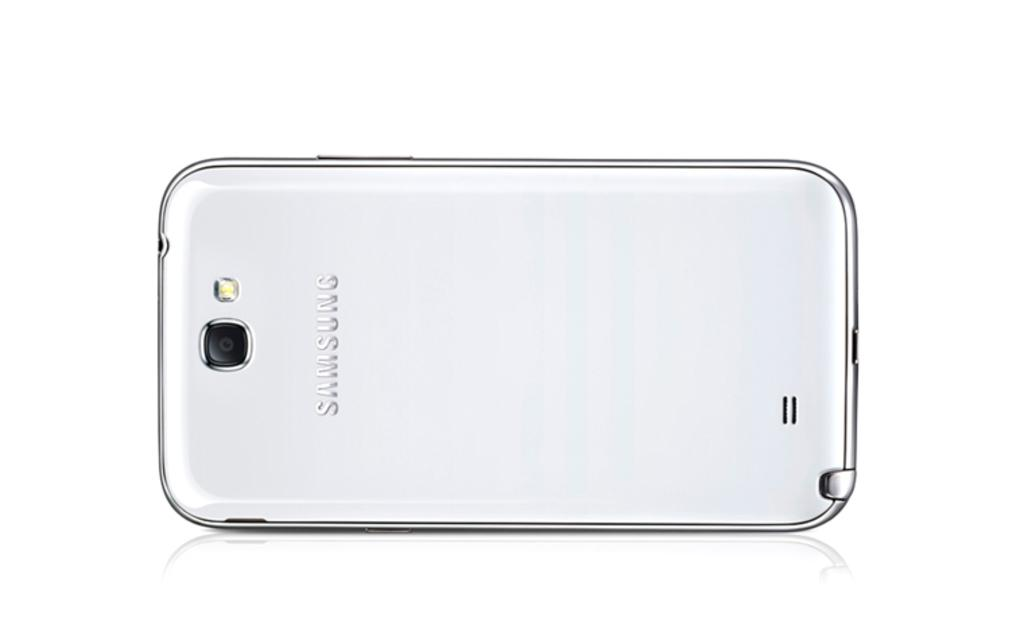<image>
Describe the image concisely. A slick silver Samsung phone has the company name on its back. 